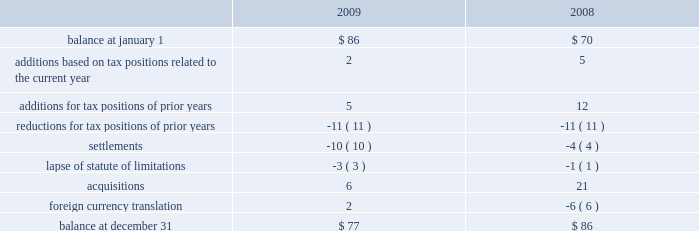At december 31 , 2009 , aon had domestic federal operating loss carryforwards of $ 7 million that will expire at various dates from 2010 to 2024 , state operating loss carryforwards of $ 513 million that will expire at various dates from 2010 to 2028 , and foreign operating and capital loss carryforwards of $ 453 million and $ 252 million , respectively , nearly all of which are subject to indefinite carryforward .
Unrecognized tax benefits the following is a reconciliation of the company 2019s beginning and ending amount of unrecognized tax benefits ( in millions ) : .
As of december 31 , 2009 , $ 61 million of unrecognized tax benefits would impact the effective tax rate if recognized .
Aon does not expect the unrecognized tax positions to change significantly over the next twelve months .
The company recognizes penalties and interest related to unrecognized income tax benefits in its provision for income taxes .
Aon accrued potential penalties of less than $ 1 million during each of 2009 , 2008 and 2007 .
Aon accrued interest of $ 2 million during 2009 and less than $ 1 million during both 2008 and 2007 .
As of december 31 , 2009 and 2008 , aon has recorded a liability for penalties of $ 5 million and $ 4 million , respectively , and for interest of $ 18 million and $ 14 million , respectively .
Aon and its subsidiaries file income tax returns in the u.s .
Federal jurisdiction as well as various state and international jurisdictions .
Aon has substantially concluded all u.s .
Federal income tax matters for years through 2006 .
Material u.s .
State and local income tax jurisdiction examinations have been concluded for years through 2002 .
Aon has concluded income tax examinations in its primary international jurisdictions through 2002. .
Considering the years 2008 and 2009 , what is the increase observed in the liability for interest? 
Rationale: it is the value of 2009 divide by the 2008's , then transformed into a percentage .
Computations: ((18 / 14) - 1)
Answer: 0.28571. 